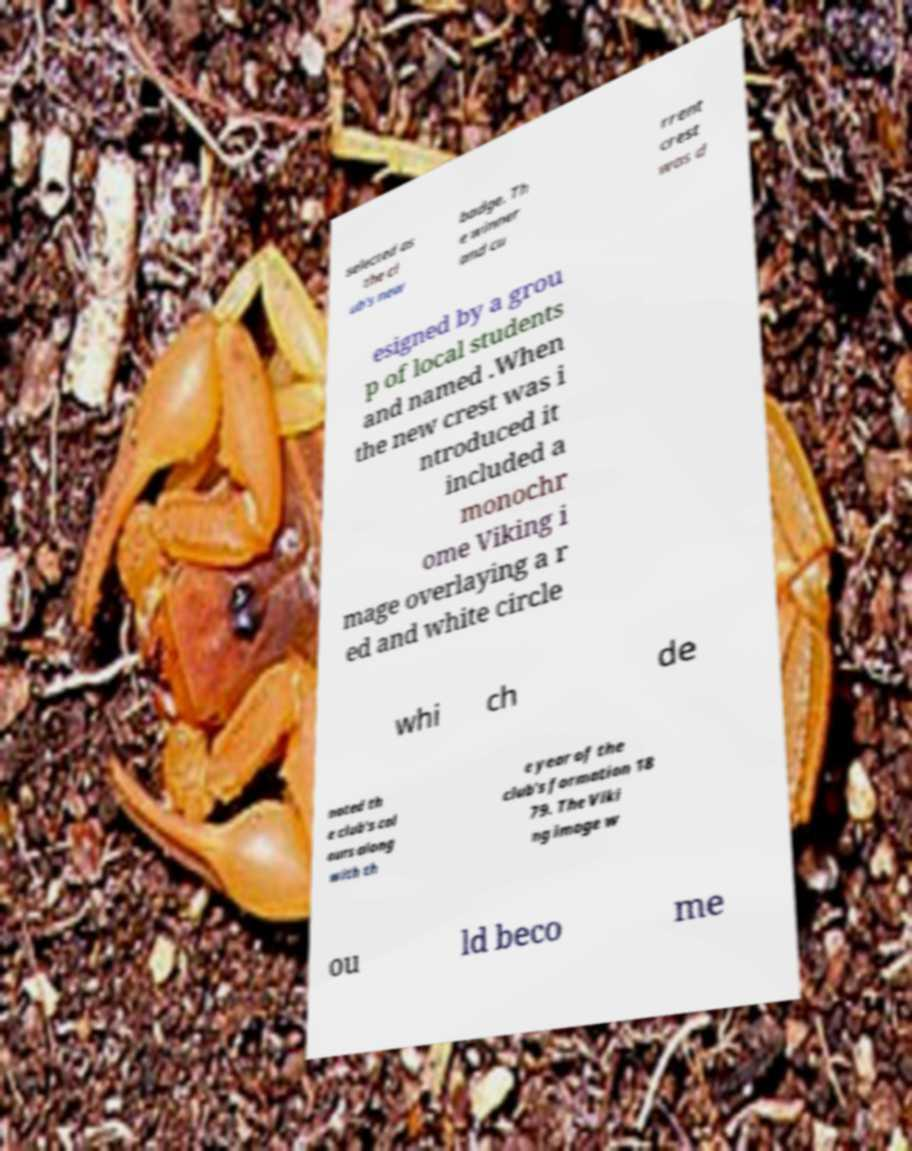Please identify and transcribe the text found in this image. selected as the cl ub's new badge. Th e winner and cu rrent crest was d esigned by a grou p of local students and named .When the new crest was i ntroduced it included a monochr ome Viking i mage overlaying a r ed and white circle whi ch de noted th e club's col ours along with th e year of the club's formation 18 79. The Viki ng image w ou ld beco me 